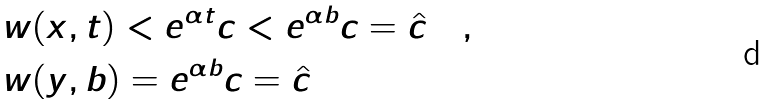Convert formula to latex. <formula><loc_0><loc_0><loc_500><loc_500>& w ( x , t ) < e ^ { \alpha t } c < e ^ { \alpha b } c = \hat { c } \quad , \\ & w ( y , b ) = e ^ { \alpha b } c = \hat { c } \quad</formula> 